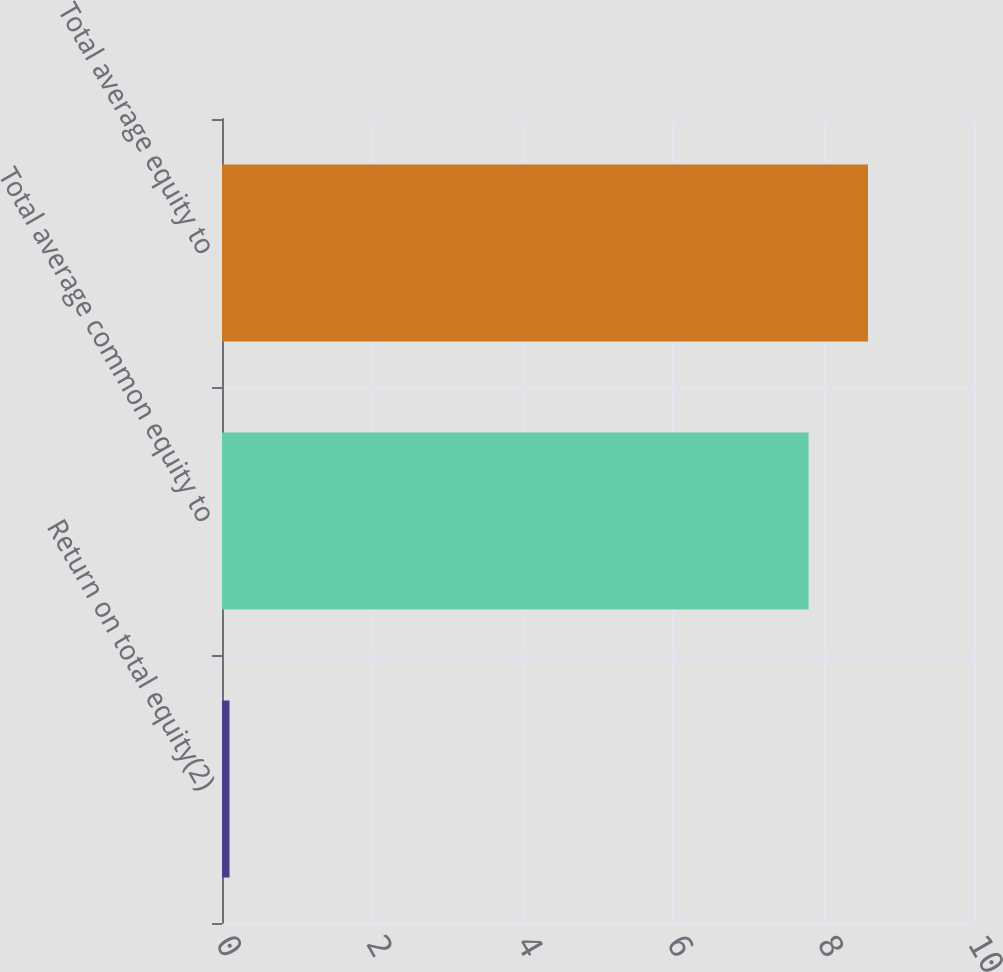<chart> <loc_0><loc_0><loc_500><loc_500><bar_chart><fcel>Return on total equity(2)<fcel>Total average common equity to<fcel>Total average equity to<nl><fcel>0.1<fcel>7.8<fcel>8.59<nl></chart> 